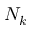<formula> <loc_0><loc_0><loc_500><loc_500>N _ { k }</formula> 